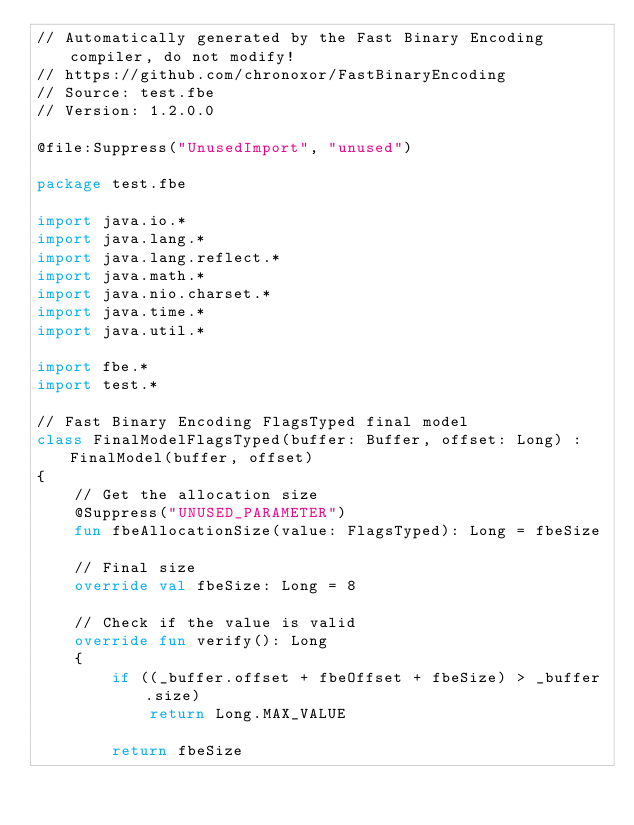Convert code to text. <code><loc_0><loc_0><loc_500><loc_500><_Kotlin_>// Automatically generated by the Fast Binary Encoding compiler, do not modify!
// https://github.com/chronoxor/FastBinaryEncoding
// Source: test.fbe
// Version: 1.2.0.0

@file:Suppress("UnusedImport", "unused")

package test.fbe

import java.io.*
import java.lang.*
import java.lang.reflect.*
import java.math.*
import java.nio.charset.*
import java.time.*
import java.util.*

import fbe.*
import test.*

// Fast Binary Encoding FlagsTyped final model
class FinalModelFlagsTyped(buffer: Buffer, offset: Long) : FinalModel(buffer, offset)
{
    // Get the allocation size
    @Suppress("UNUSED_PARAMETER")
    fun fbeAllocationSize(value: FlagsTyped): Long = fbeSize

    // Final size
    override val fbeSize: Long = 8

    // Check if the value is valid
    override fun verify(): Long
    {
        if ((_buffer.offset + fbeOffset + fbeSize) > _buffer.size)
            return Long.MAX_VALUE

        return fbeSize</code> 